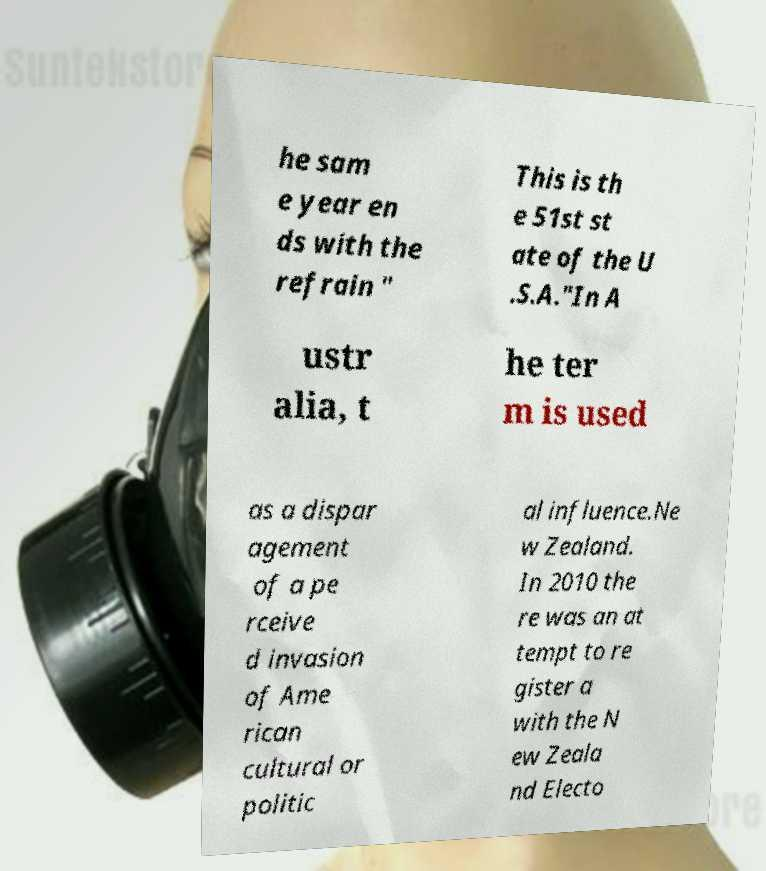For documentation purposes, I need the text within this image transcribed. Could you provide that? he sam e year en ds with the refrain " This is th e 51st st ate of the U .S.A."In A ustr alia, t he ter m is used as a dispar agement of a pe rceive d invasion of Ame rican cultural or politic al influence.Ne w Zealand. In 2010 the re was an at tempt to re gister a with the N ew Zeala nd Electo 